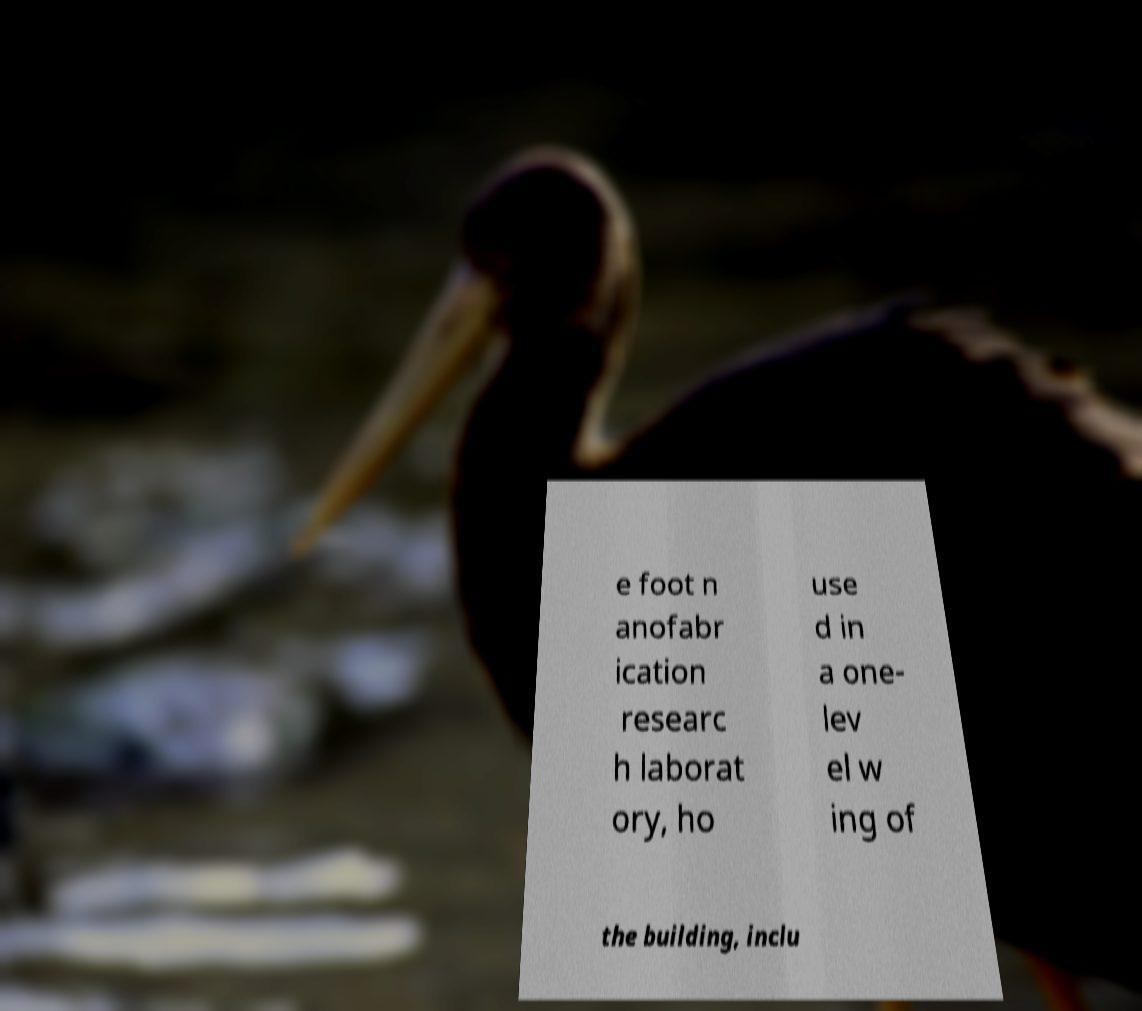Please identify and transcribe the text found in this image. e foot n anofabr ication researc h laborat ory, ho use d in a one- lev el w ing of the building, inclu 